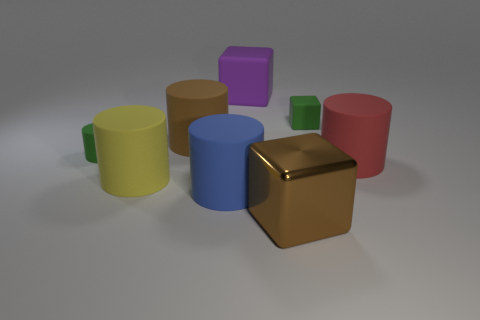What time of day does it look like based on the lighting in the image? The lighting in the image suggests an indoor scenario, likely illuminated by artificial light sources, as indicated by the soft shadows and the even light distribution across the objects. What kind of mood does the lighting create in the image? The lighting creates a calm and neutral mood, with gentle shadows that provide a sense of depth without any harsh contrasts, suggesting a tranquil and controlled environment. 